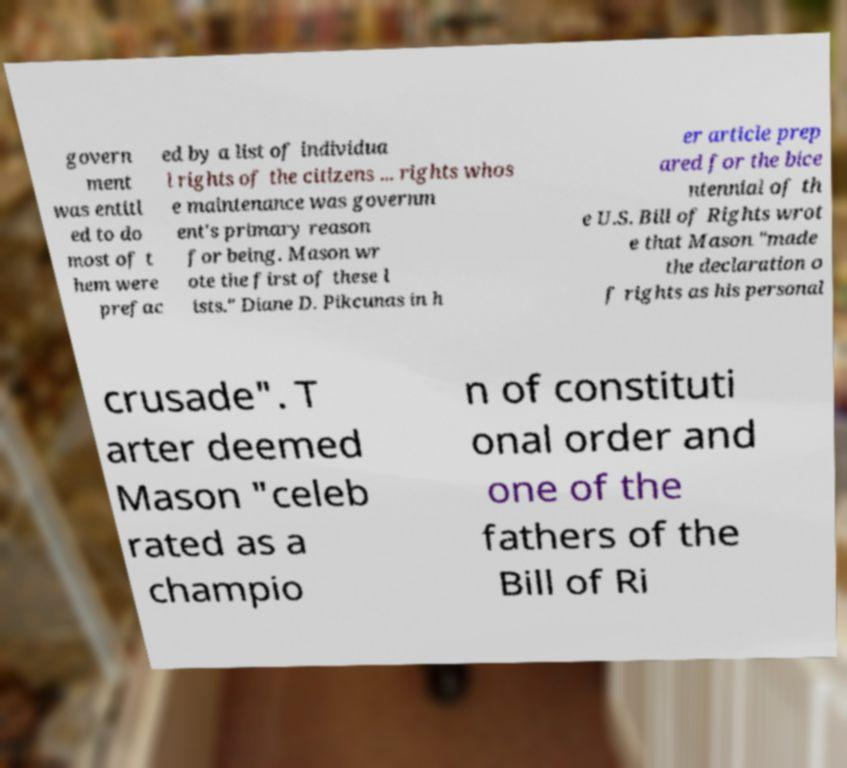What messages or text are displayed in this image? I need them in a readable, typed format. govern ment was entitl ed to do most of t hem were prefac ed by a list of individua l rights of the citizens ... rights whos e maintenance was governm ent's primary reason for being. Mason wr ote the first of these l ists." Diane D. Pikcunas in h er article prep ared for the bice ntennial of th e U.S. Bill of Rights wrot e that Mason "made the declaration o f rights as his personal crusade". T arter deemed Mason "celeb rated as a champio n of constituti onal order and one of the fathers of the Bill of Ri 